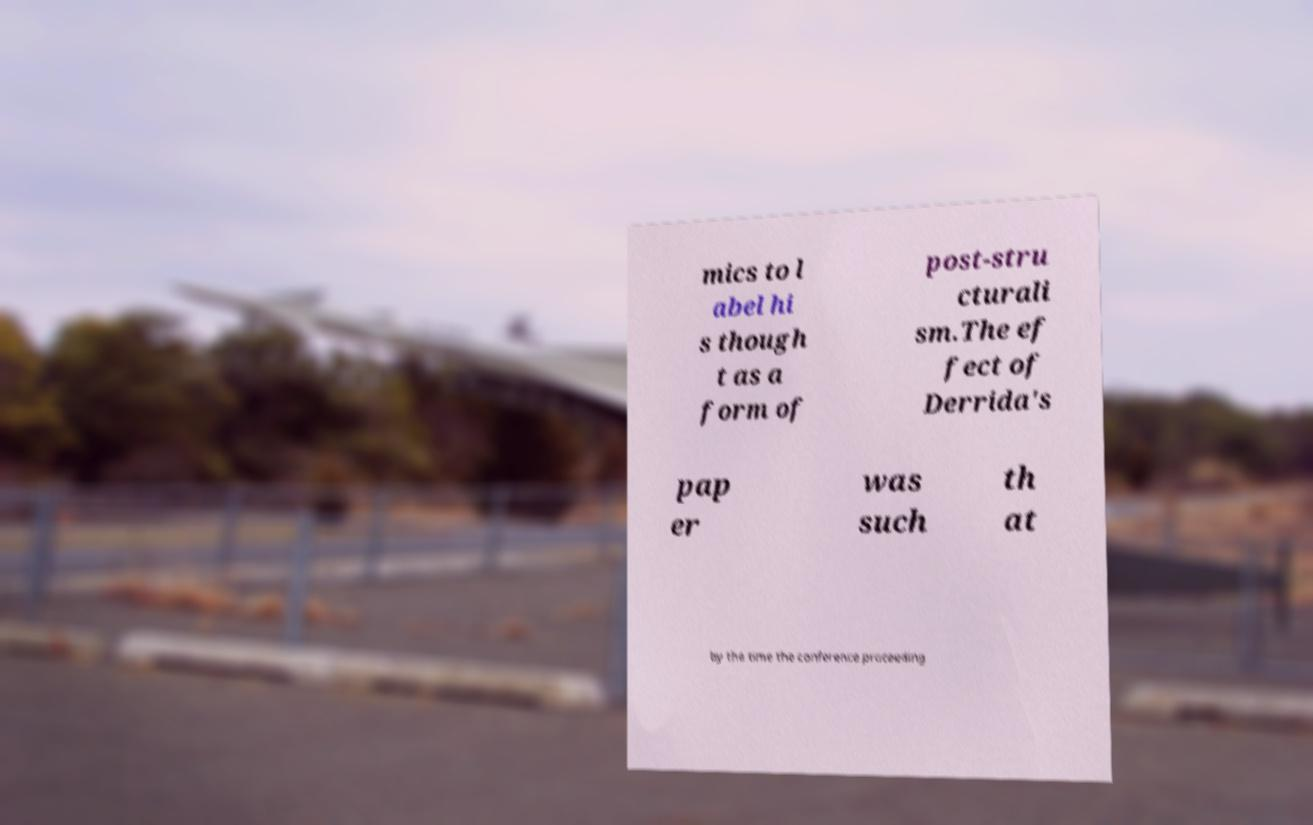Please read and relay the text visible in this image. What does it say? mics to l abel hi s though t as a form of post-stru cturali sm.The ef fect of Derrida's pap er was such th at by the time the conference proceeding 